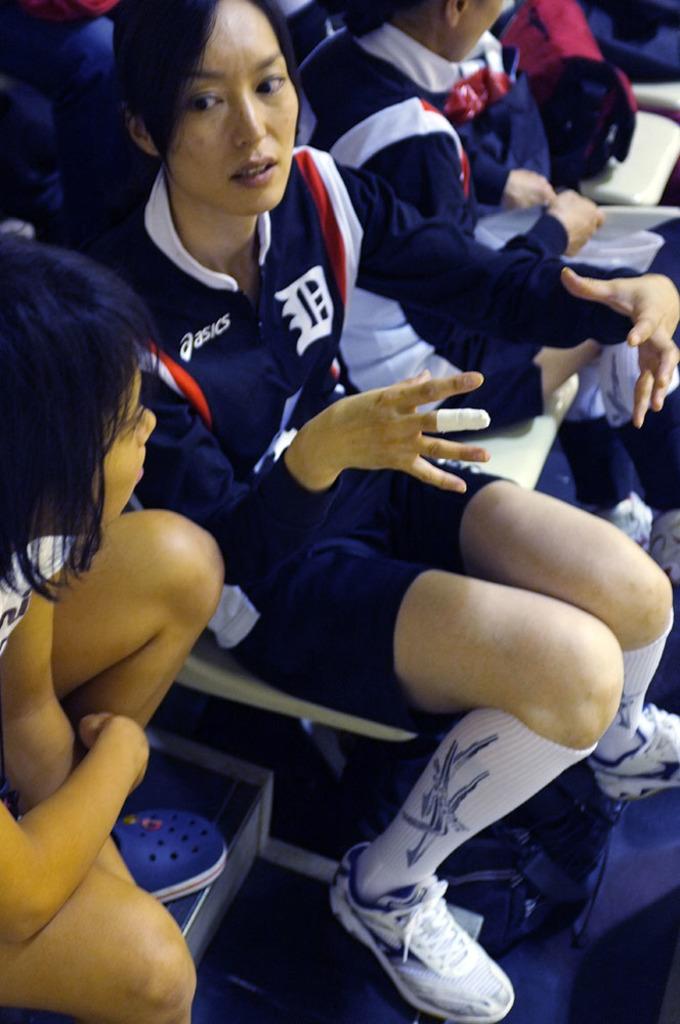What sports company produces this athlete's shirt?
Make the answer very short. Asics. Does asics brand sponsor this team?
Your answer should be very brief. Yes. 